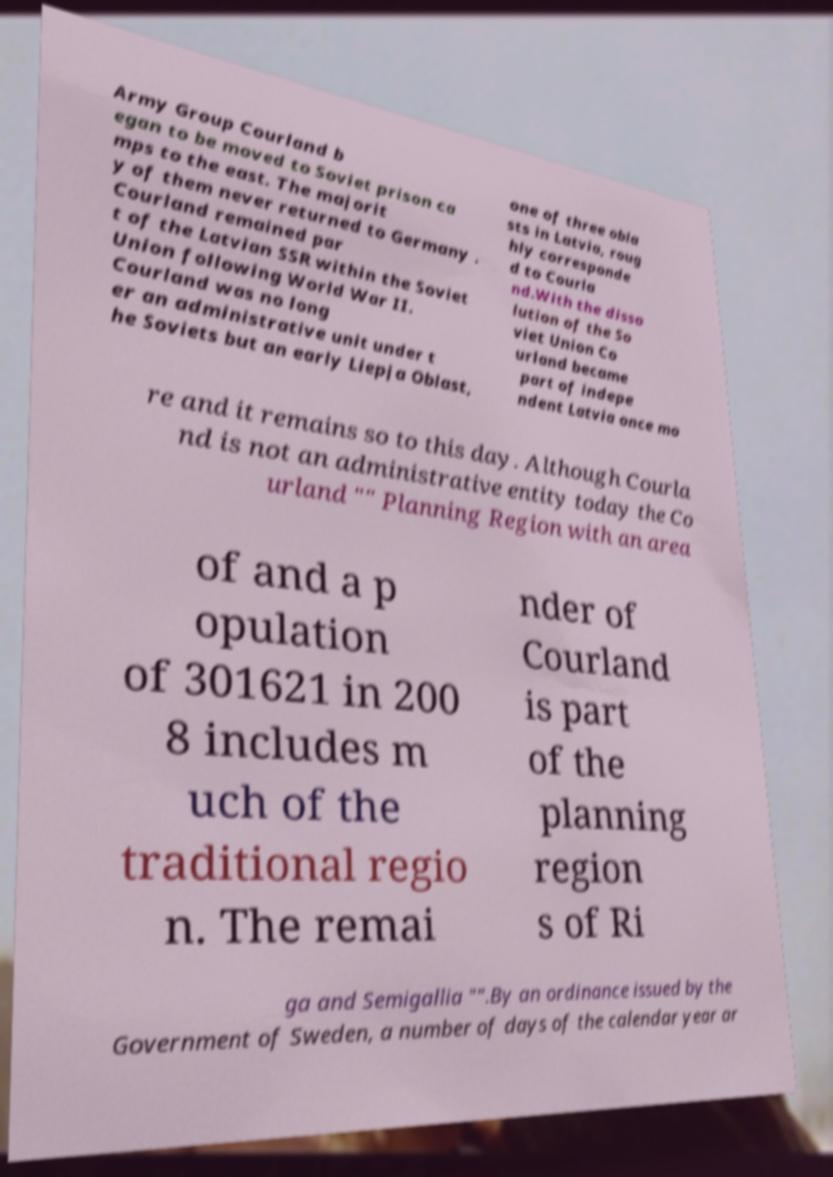Please identify and transcribe the text found in this image. Army Group Courland b egan to be moved to Soviet prison ca mps to the east. The majorit y of them never returned to Germany . Courland remained par t of the Latvian SSR within the Soviet Union following World War II. Courland was no long er an administrative unit under t he Soviets but an early Liepja Oblast, one of three obla sts in Latvia, roug hly corresponde d to Courla nd.With the disso lution of the So viet Union Co urland became part of indepe ndent Latvia once mo re and it remains so to this day. Although Courla nd is not an administrative entity today the Co urland "" Planning Region with an area of and a p opulation of 301621 in 200 8 includes m uch of the traditional regio n. The remai nder of Courland is part of the planning region s of Ri ga and Semigallia "".By an ordinance issued by the Government of Sweden, a number of days of the calendar year ar 